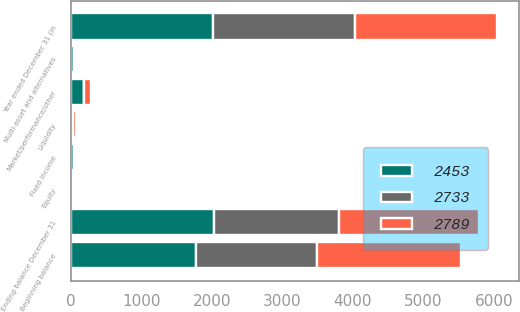Convert chart to OTSL. <chart><loc_0><loc_0><loc_500><loc_500><stacked_bar_chart><ecel><fcel>Year ended December 31 (in<fcel>Beginning balance<fcel>Liquidity<fcel>Fixed income<fcel>Equity<fcel>Multi-asset and alternatives<fcel>Market/performance/other<fcel>Ending balance December 31<nl><fcel>2789<fcel>2018<fcel>2034<fcel>31<fcel>1<fcel>2<fcel>24<fcel>103<fcel>1987<nl><fcel>2453<fcel>2017<fcel>1771<fcel>9<fcel>36<fcel>11<fcel>43<fcel>186<fcel>2034<nl><fcel>2733<fcel>2016<fcel>1723<fcel>24<fcel>30<fcel>29<fcel>22<fcel>1<fcel>1771<nl></chart> 